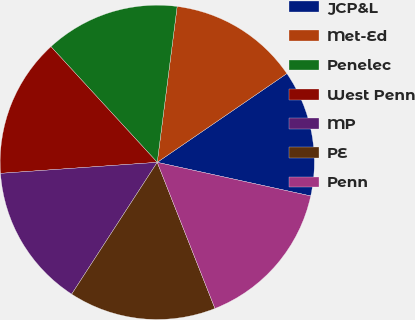Convert chart to OTSL. <chart><loc_0><loc_0><loc_500><loc_500><pie_chart><fcel>JCP&L<fcel>Met-Ed<fcel>Penelec<fcel>West Penn<fcel>MP<fcel>PE<fcel>Penn<nl><fcel>12.99%<fcel>13.42%<fcel>13.85%<fcel>14.29%<fcel>14.72%<fcel>15.15%<fcel>15.58%<nl></chart> 